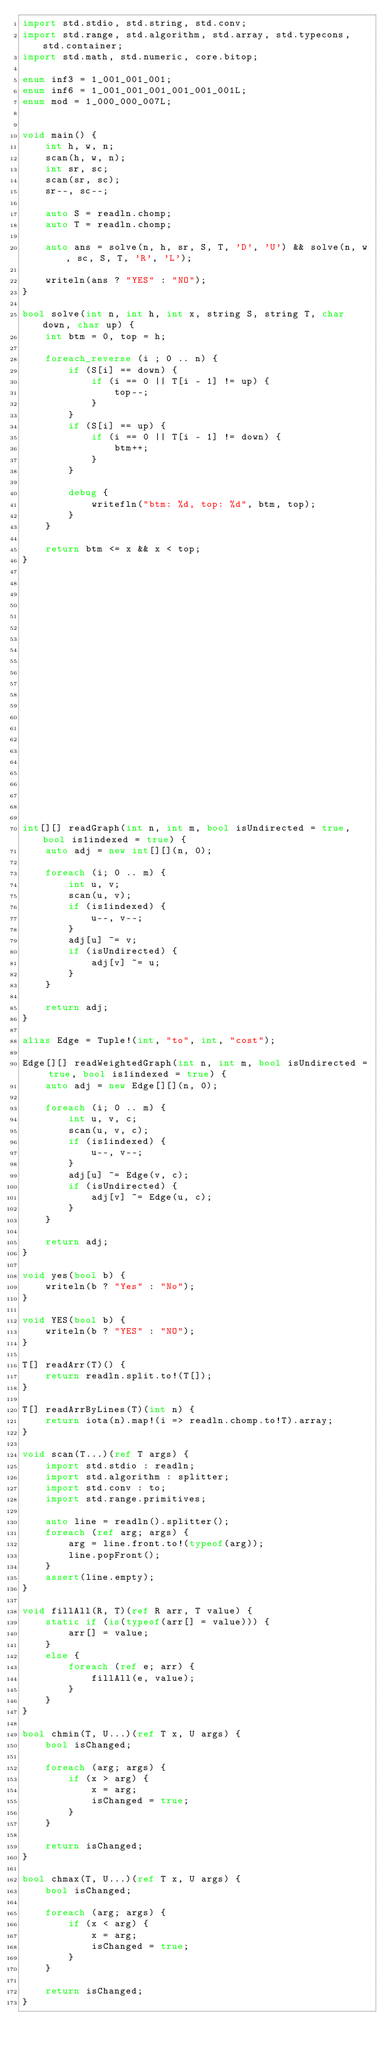Convert code to text. <code><loc_0><loc_0><loc_500><loc_500><_D_>import std.stdio, std.string, std.conv;
import std.range, std.algorithm, std.array, std.typecons, std.container;
import std.math, std.numeric, core.bitop;

enum inf3 = 1_001_001_001;
enum inf6 = 1_001_001_001_001_001_001L;
enum mod = 1_000_000_007L;


void main() {
    int h, w, n;
    scan(h, w, n);
    int sr, sc;
    scan(sr, sc);
    sr--, sc--;

    auto S = readln.chomp;
    auto T = readln.chomp;

    auto ans = solve(n, h, sr, S, T, 'D', 'U') && solve(n, w, sc, S, T, 'R', 'L');

    writeln(ans ? "YES" : "NO");
}

bool solve(int n, int h, int x, string S, string T, char down, char up) {
    int btm = 0, top = h;

    foreach_reverse (i ; 0 .. n) {
        if (S[i] == down) {
            if (i == 0 || T[i - 1] != up) {
                top--;
            }
        }
        if (S[i] == up) {
            if (i == 0 || T[i - 1] != down) {
                btm++;
            }
        }

        debug {
            writefln("btm: %d, top: %d", btm, top);
        }
    }

    return btm <= x && x < top;
}























int[][] readGraph(int n, int m, bool isUndirected = true, bool is1indexed = true) {
    auto adj = new int[][](n, 0);

    foreach (i; 0 .. m) {
        int u, v;
        scan(u, v);
        if (is1indexed) {
            u--, v--;
        }
        adj[u] ~= v;
        if (isUndirected) {
            adj[v] ~= u;
        }
    }

    return adj;
}

alias Edge = Tuple!(int, "to", int, "cost");

Edge[][] readWeightedGraph(int n, int m, bool isUndirected = true, bool is1indexed = true) {
    auto adj = new Edge[][](n, 0);

    foreach (i; 0 .. m) {
        int u, v, c;
        scan(u, v, c);
        if (is1indexed) {
            u--, v--;
        }
        adj[u] ~= Edge(v, c);
        if (isUndirected) {
            adj[v] ~= Edge(u, c);
        }
    }

    return adj;
}

void yes(bool b) {
    writeln(b ? "Yes" : "No");
}

void YES(bool b) {
    writeln(b ? "YES" : "NO");
}

T[] readArr(T)() {
    return readln.split.to!(T[]);
}

T[] readArrByLines(T)(int n) {
    return iota(n).map!(i => readln.chomp.to!T).array;
}

void scan(T...)(ref T args) {
    import std.stdio : readln;
    import std.algorithm : splitter;
    import std.conv : to;
    import std.range.primitives;

    auto line = readln().splitter();
    foreach (ref arg; args) {
        arg = line.front.to!(typeof(arg));
        line.popFront();
    }
    assert(line.empty);
}

void fillAll(R, T)(ref R arr, T value) {
    static if (is(typeof(arr[] = value))) {
        arr[] = value;
    }
    else {
        foreach (ref e; arr) {
            fillAll(e, value);
        }
    }
}

bool chmin(T, U...)(ref T x, U args) {
    bool isChanged;

    foreach (arg; args) {
        if (x > arg) {
            x = arg;
            isChanged = true;
        }
    }

    return isChanged;
}

bool chmax(T, U...)(ref T x, U args) {
    bool isChanged;

    foreach (arg; args) {
        if (x < arg) {
            x = arg;
            isChanged = true;
        }
    }

    return isChanged;
}
</code> 